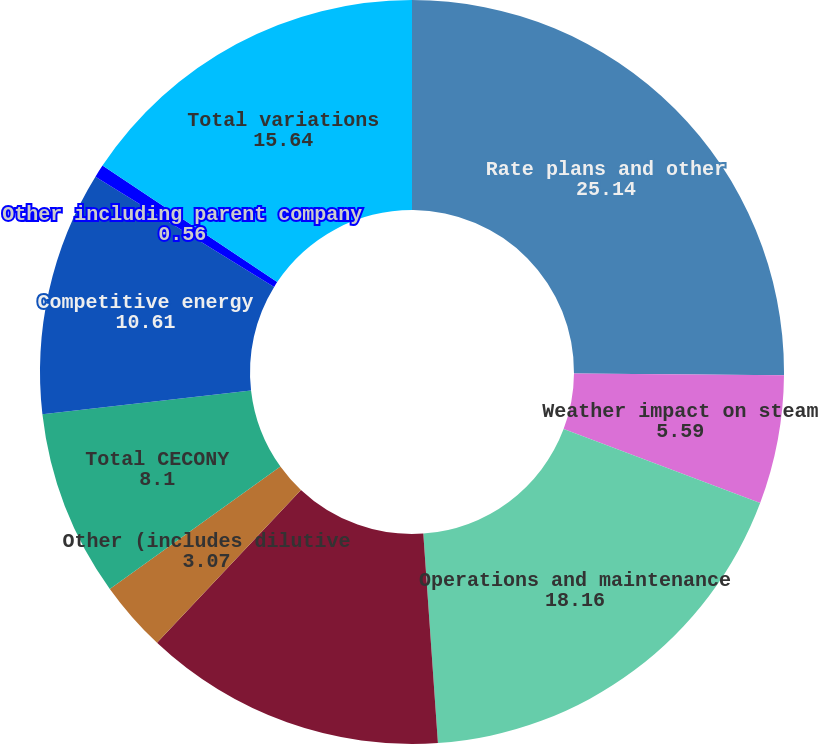<chart> <loc_0><loc_0><loc_500><loc_500><pie_chart><fcel>Rate plans and other<fcel>Weather impact on steam<fcel>Operations and maintenance<fcel>Depreciation and amortization<fcel>Other (includes dilutive<fcel>Total CECONY<fcel>Competitive energy<fcel>Other including parent company<fcel>Total variations<nl><fcel>25.14%<fcel>5.59%<fcel>18.16%<fcel>13.13%<fcel>3.07%<fcel>8.1%<fcel>10.61%<fcel>0.56%<fcel>15.64%<nl></chart> 